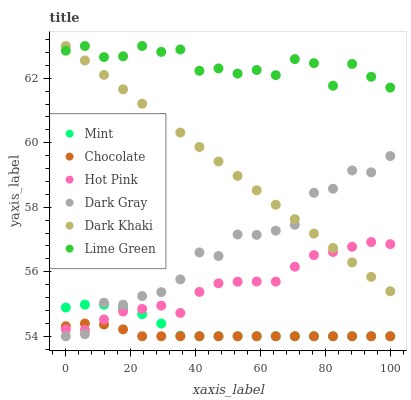Does Chocolate have the minimum area under the curve?
Answer yes or no. Yes. Does Lime Green have the maximum area under the curve?
Answer yes or no. Yes. Does Hot Pink have the minimum area under the curve?
Answer yes or no. No. Does Hot Pink have the maximum area under the curve?
Answer yes or no. No. Is Dark Khaki the smoothest?
Answer yes or no. Yes. Is Dark Gray the roughest?
Answer yes or no. Yes. Is Lime Green the smoothest?
Answer yes or no. No. Is Lime Green the roughest?
Answer yes or no. No. Does Chocolate have the lowest value?
Answer yes or no. Yes. Does Hot Pink have the lowest value?
Answer yes or no. No. Does Lime Green have the highest value?
Answer yes or no. Yes. Does Hot Pink have the highest value?
Answer yes or no. No. Is Chocolate less than Lime Green?
Answer yes or no. Yes. Is Lime Green greater than Mint?
Answer yes or no. Yes. Does Chocolate intersect Dark Gray?
Answer yes or no. Yes. Is Chocolate less than Dark Gray?
Answer yes or no. No. Is Chocolate greater than Dark Gray?
Answer yes or no. No. Does Chocolate intersect Lime Green?
Answer yes or no. No. 